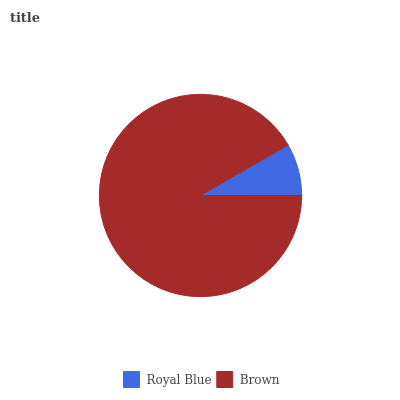Is Royal Blue the minimum?
Answer yes or no. Yes. Is Brown the maximum?
Answer yes or no. Yes. Is Brown the minimum?
Answer yes or no. No. Is Brown greater than Royal Blue?
Answer yes or no. Yes. Is Royal Blue less than Brown?
Answer yes or no. Yes. Is Royal Blue greater than Brown?
Answer yes or no. No. Is Brown less than Royal Blue?
Answer yes or no. No. Is Brown the high median?
Answer yes or no. Yes. Is Royal Blue the low median?
Answer yes or no. Yes. Is Royal Blue the high median?
Answer yes or no. No. Is Brown the low median?
Answer yes or no. No. 